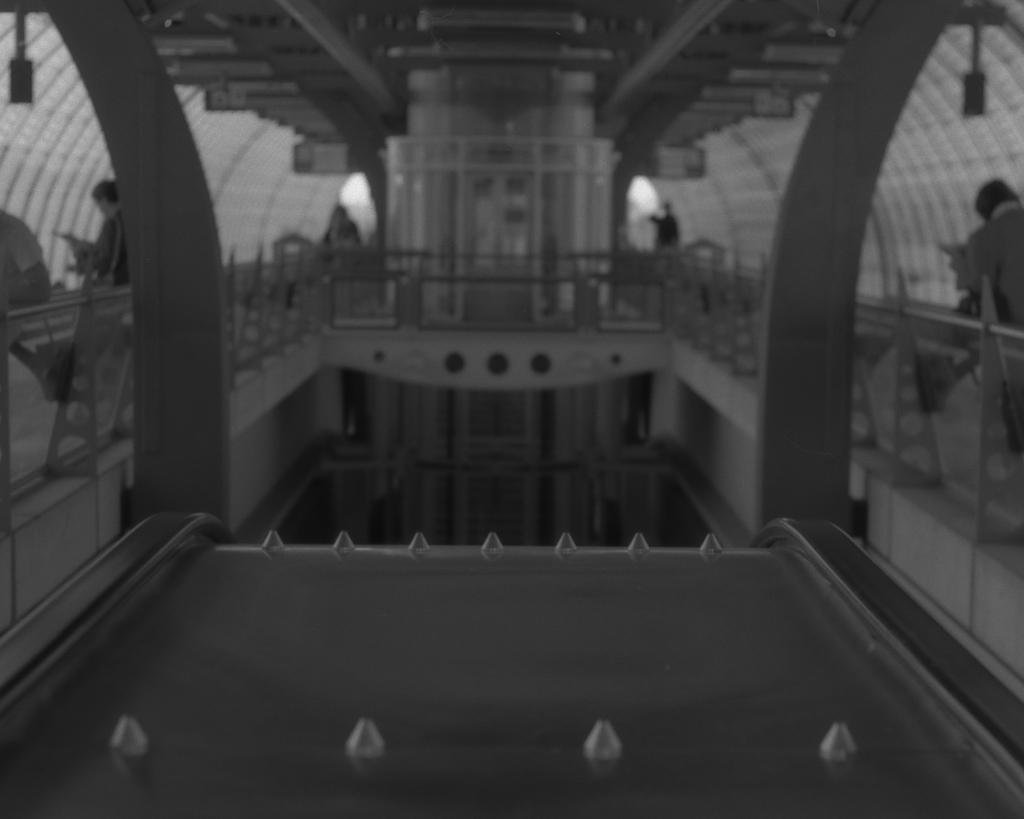What is the main structure in the center of the image? There is a palace in the center of the image. Where are the people located in the image? There are people on both the right and left sides of the image. What type of thrill ride can be seen in the image? There is no thrill ride present in the image; it features a palace and people. How many cherries are visible on the palace in the image? There are no cherries present on the palace in the image. 